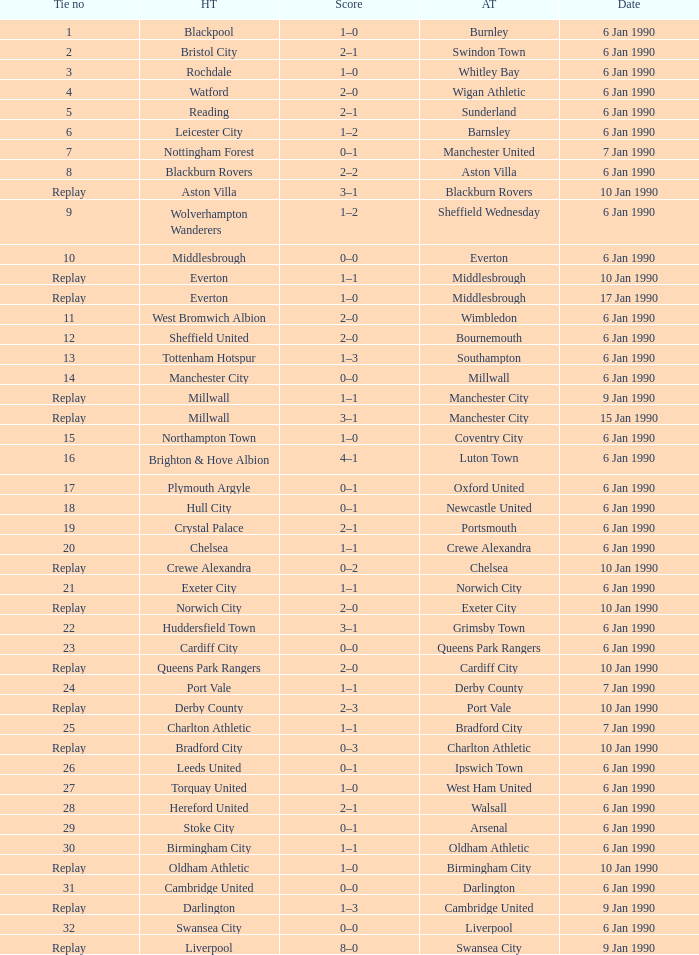What date did home team liverpool play? 9 Jan 1990. 